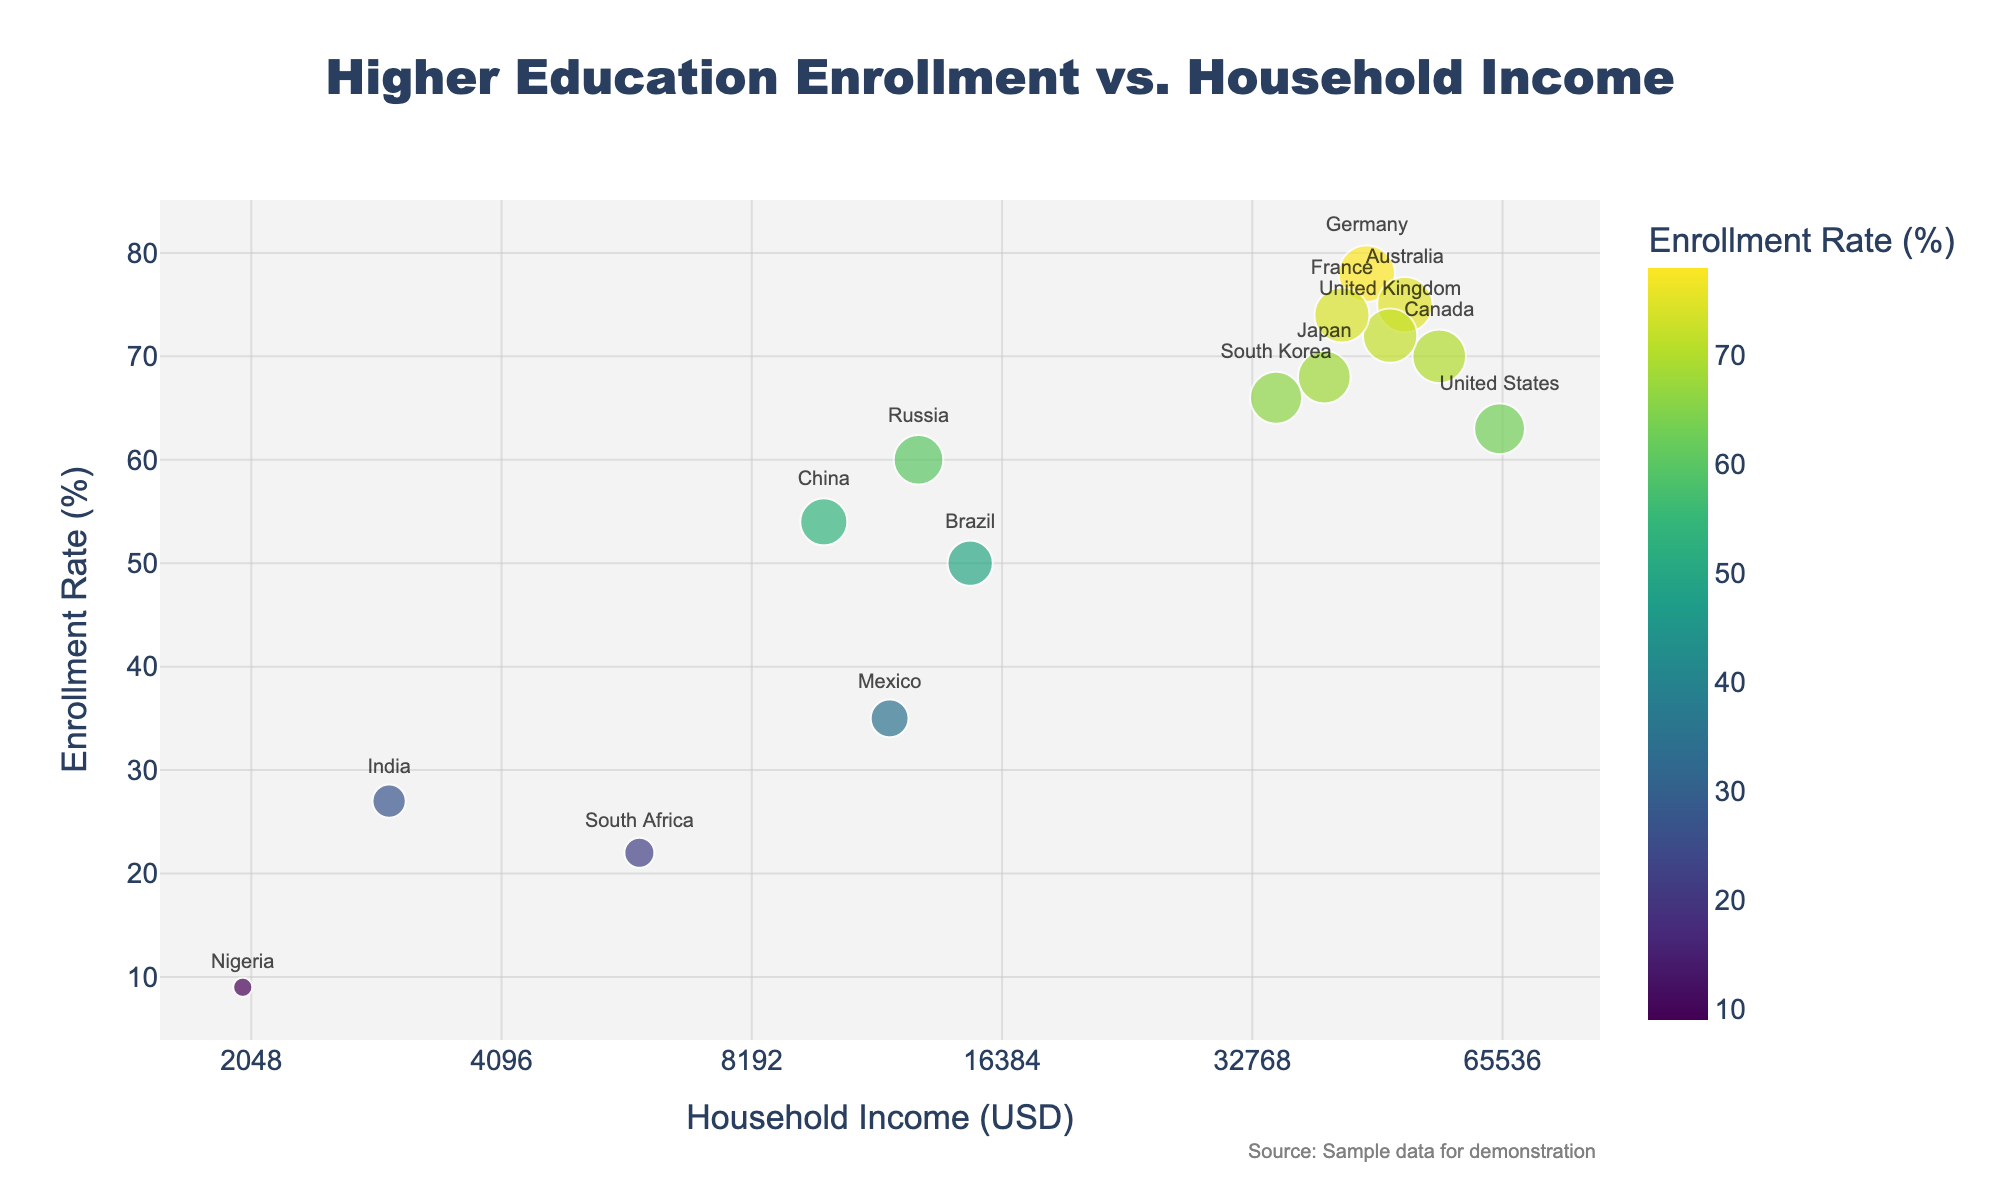What is the title of the scatter plot? The title of the scatter plot is usually displayed at the top of the chart. In this case, the title is "Higher Education Enrollment vs. Household Income".
Answer: Higher Education Enrollment vs. Household Income Which country has the highest enrollment rate in higher education? By examining the scatter plot, the country with the data point positioned highest on the y-axis represents the highest enrollment rate. Germany has the highest enrollment rate at 78%.
Answer: Germany What is the household income value for India? Locate the data point labeled "India" and trace it down to the x-axis to find the corresponding household income value, which is 3000 USD.
Answer: 3000 USD Compare the enrollment rates of the United States and United Kingdom. Identify the respective data points for the United States and United Kingdom on the scatter plot. The United States has an enrollment rate of 63%, while the United Kingdom has an enrollment rate of 72%.
Answer: United States: 63%, United Kingdom: 72% Which country has the lowest household income, and what is its enrollment rate? The country positioned farthest to the left on the x-axis represents the lowest household income. Nigeria has the lowest household income at 2000 USD and an enrollment rate of 9%.
Answer: Nigeria, Enrollment Rate: 9% What is the median household income value among the countries described in the scatter plot? To find the median, list the household income values in ascending order: 2000, 3000, 6000, 10000, 12000, 13000, 15000, 35000, 40000, 42000, 45000, 48000, 50000, 55000, 65000. The median value is the middle value in this ordered list, which is 15000 USD.
Answer: 15000 USD How does the enrollment rate in Japan compare to that in Canada? Identify the data points for Japan and Canada. Japan has an enrollment rate of 68%, while Canada has an enrollment rate of 70%.
Answer: Japan: 68%, Canada: 70% Which country has a household income of approximately 12,000 USD, and what is its enrollment rate? Locate the data point closest to the 12,000 USD mark on the log scale x-axis. Mexico has a household income of approximately 12,000 USD and an enrollment rate of 35%.
Answer: Mexico, Enrollment Rate: 35% Among countries with a household income above 40,000 USD, which country has the lowest enrollment rate, and what is that rate? Filter the data points to include only those with household incomes above 40,000 USD. Among United States, Japan, Canada, Australia, United Kingdom, France, Germany, the United States has the lowest enrollment rate at 63%.
Answer: United States, Enrollment Rate: 63% 